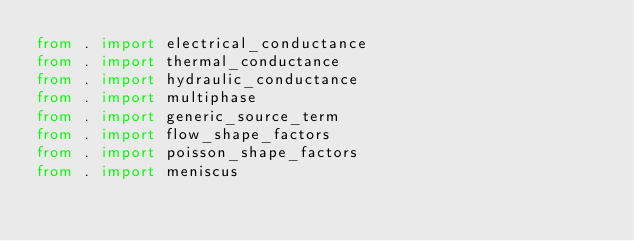Convert code to text. <code><loc_0><loc_0><loc_500><loc_500><_Python_>from . import electrical_conductance
from . import thermal_conductance
from . import hydraulic_conductance
from . import multiphase
from . import generic_source_term
from . import flow_shape_factors
from . import poisson_shape_factors
from . import meniscus
</code> 